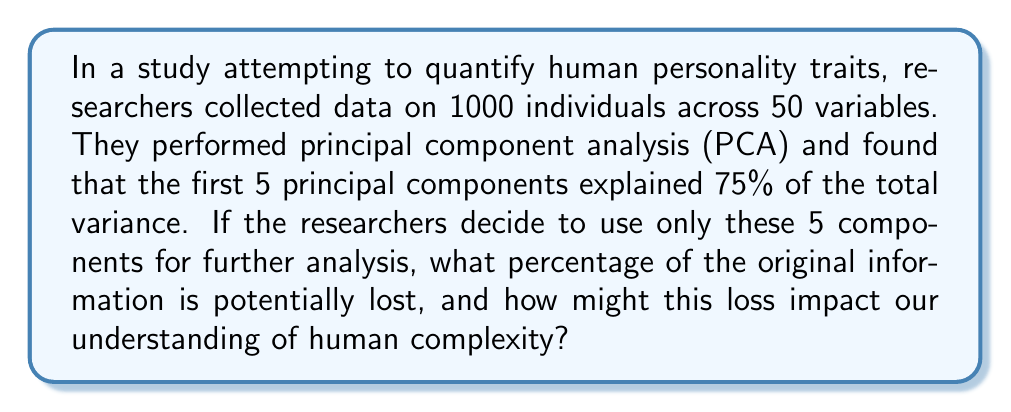Solve this math problem. To approach this problem, we need to consider the following steps:

1) In PCA, the total variance in the dataset is distributed across all principal components. The percentage of variance explained by each component indicates how much of the original information it captures.

2) Given:
   - The first 5 principal components explain 75% of the total variance.
   - There are 50 original variables.

3) The percentage of variance not explained by the first 5 components:
   $$100\% - 75\% = 25\%$$

4) This 25% represents the potential loss of information if only the first 5 components are used.

5) To calculate the average amount of information contained in each of the remaining components:
   $$\frac{25\%}{50 - 5} = \frac{25\%}{45} \approx 0.56\%$$

6) This means that each of the discarded components contains, on average, 0.56% of the total information.

From a philosophical perspective, this loss of information is crucial. While PCA is mathematically sound, it assumes that the most important aspects of human personality can be captured by linear combinations of variables with the highest variance. However, human complexity often lies in subtle, non-linear interactions that may be represented by components with lower variance.

The 25% loss might include:
- Rare but significant personality traits
- Complex interactions between traits
- Cultural or contextual nuances
- Individual idiosyncrasies

These aspects, while potentially less prominent in terms of statistical variance, could be fundamental to understanding the full spectrum of human experience and individuality.

Therefore, while PCA provides a useful dimensional reduction, it may oversimplify the multifaceted nature of human personality, potentially reinforcing the philosophical stance that empirical methods have limitations in fully capturing the essence of human experience.
Answer: 25% of the original information is potentially lost. This loss may significantly impact our understanding of human complexity by overlooking rare traits, complex interactions, cultural nuances, and individual idiosyncrasies that are crucial for a comprehensive view of human personality and experience. 